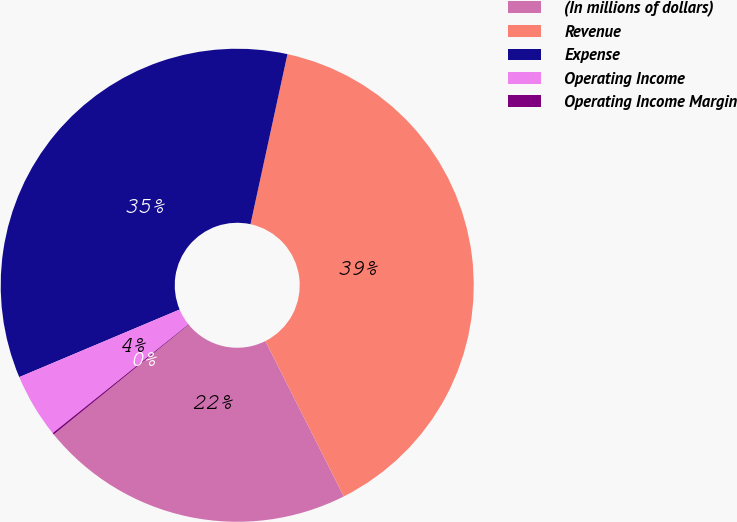<chart> <loc_0><loc_0><loc_500><loc_500><pie_chart><fcel>(In millions of dollars)<fcel>Revenue<fcel>Expense<fcel>Operating Income<fcel>Operating Income Margin<nl><fcel>21.57%<fcel>39.15%<fcel>34.75%<fcel>4.4%<fcel>0.12%<nl></chart> 